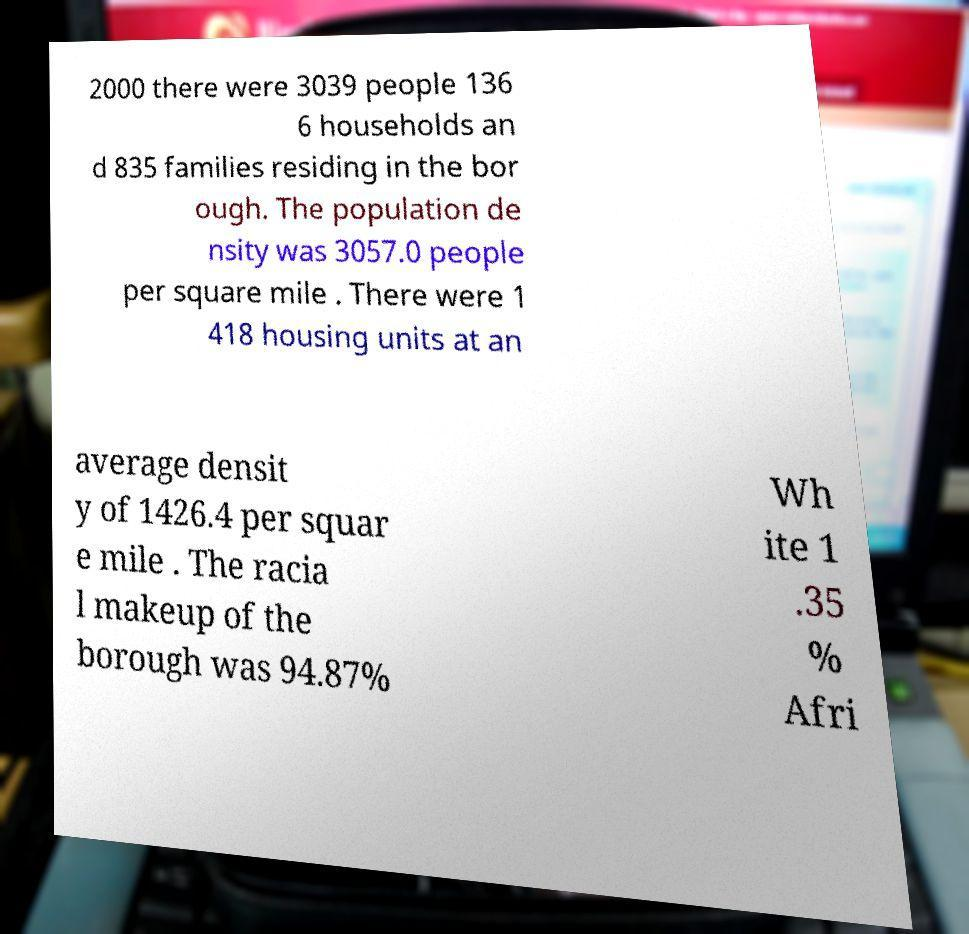Could you assist in decoding the text presented in this image and type it out clearly? 2000 there were 3039 people 136 6 households an d 835 families residing in the bor ough. The population de nsity was 3057.0 people per square mile . There were 1 418 housing units at an average densit y of 1426.4 per squar e mile . The racia l makeup of the borough was 94.87% Wh ite 1 .35 % Afri 